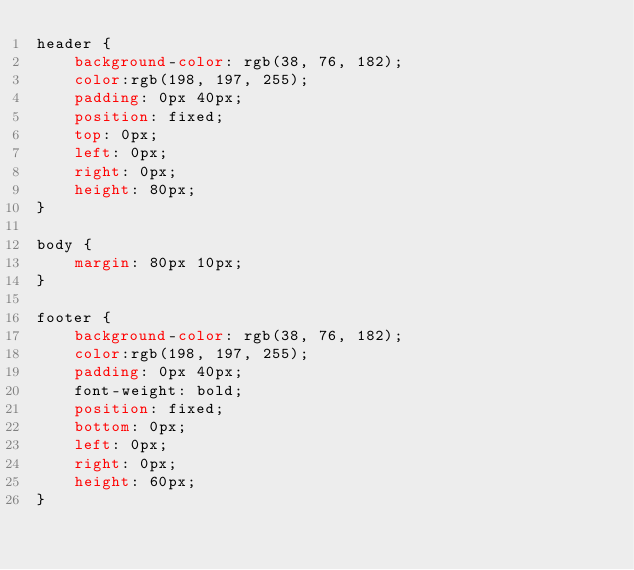Convert code to text. <code><loc_0><loc_0><loc_500><loc_500><_CSS_>header {
    background-color: rgb(38, 76, 182);
    color:rgb(198, 197, 255);
    padding: 0px 40px;
    position: fixed;
    top: 0px;
    left: 0px;
    right: 0px;
    height: 80px;
}

body {
    margin: 80px 10px;
}

footer {
    background-color: rgb(38, 76, 182);
    color:rgb(198, 197, 255);
    padding: 0px 40px;
    font-weight: bold;
    position: fixed;
    bottom: 0px;
    left: 0px;
    right: 0px;
    height: 60px;
}</code> 